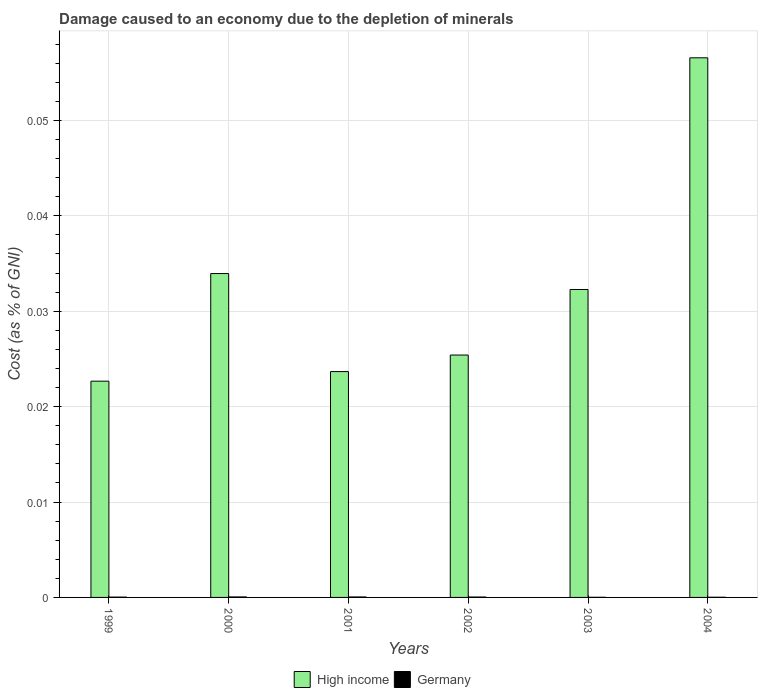How many different coloured bars are there?
Provide a succinct answer. 2. How many groups of bars are there?
Give a very brief answer. 6. How many bars are there on the 3rd tick from the left?
Offer a terse response. 2. In how many cases, is the number of bars for a given year not equal to the number of legend labels?
Your response must be concise. 0. What is the cost of damage caused due to the depletion of minerals in Germany in 1999?
Provide a short and direct response. 3.42242531159718e-5. Across all years, what is the maximum cost of damage caused due to the depletion of minerals in Germany?
Offer a very short reply. 5.218573212703661e-5. Across all years, what is the minimum cost of damage caused due to the depletion of minerals in High income?
Provide a short and direct response. 0.02. In which year was the cost of damage caused due to the depletion of minerals in Germany maximum?
Offer a terse response. 2000. What is the total cost of damage caused due to the depletion of minerals in Germany in the graph?
Your answer should be compact. 0. What is the difference between the cost of damage caused due to the depletion of minerals in Germany in 2000 and that in 2002?
Provide a short and direct response. 1.077346914888501e-5. What is the difference between the cost of damage caused due to the depletion of minerals in Germany in 2000 and the cost of damage caused due to the depletion of minerals in High income in 2002?
Offer a very short reply. -0.03. What is the average cost of damage caused due to the depletion of minerals in Germany per year?
Keep it short and to the point. 3.511987474264864e-5. In the year 2003, what is the difference between the cost of damage caused due to the depletion of minerals in High income and cost of damage caused due to the depletion of minerals in Germany?
Ensure brevity in your answer.  0.03. In how many years, is the cost of damage caused due to the depletion of minerals in Germany greater than 0.02 %?
Offer a terse response. 0. What is the ratio of the cost of damage caused due to the depletion of minerals in High income in 2000 to that in 2003?
Your answer should be compact. 1.05. Is the cost of damage caused due to the depletion of minerals in Germany in 2000 less than that in 2004?
Offer a very short reply. No. What is the difference between the highest and the second highest cost of damage caused due to the depletion of minerals in High income?
Offer a very short reply. 0.02. What is the difference between the highest and the lowest cost of damage caused due to the depletion of minerals in High income?
Provide a short and direct response. 0.03. What does the 2nd bar from the right in 2001 represents?
Provide a succinct answer. High income. How many bars are there?
Give a very brief answer. 12. How many years are there in the graph?
Your answer should be very brief. 6. What is the difference between two consecutive major ticks on the Y-axis?
Your answer should be very brief. 0.01. Does the graph contain any zero values?
Your answer should be compact. No. Where does the legend appear in the graph?
Your response must be concise. Bottom center. How are the legend labels stacked?
Provide a succinct answer. Horizontal. What is the title of the graph?
Keep it short and to the point. Damage caused to an economy due to the depletion of minerals. Does "Canada" appear as one of the legend labels in the graph?
Your answer should be very brief. No. What is the label or title of the Y-axis?
Offer a very short reply. Cost (as % of GNI). What is the Cost (as % of GNI) in High income in 1999?
Make the answer very short. 0.02. What is the Cost (as % of GNI) in Germany in 1999?
Keep it short and to the point. 3.42242531159718e-5. What is the Cost (as % of GNI) of High income in 2000?
Ensure brevity in your answer.  0.03. What is the Cost (as % of GNI) of Germany in 2000?
Make the answer very short. 5.218573212703661e-5. What is the Cost (as % of GNI) in High income in 2001?
Give a very brief answer. 0.02. What is the Cost (as % of GNI) in Germany in 2001?
Offer a very short reply. 4.8714493152778e-5. What is the Cost (as % of GNI) of High income in 2002?
Your response must be concise. 0.03. What is the Cost (as % of GNI) in Germany in 2002?
Your response must be concise. 4.14122629781516e-5. What is the Cost (as % of GNI) of High income in 2003?
Provide a succinct answer. 0.03. What is the Cost (as % of GNI) in Germany in 2003?
Ensure brevity in your answer.  1.49081092757522e-5. What is the Cost (as % of GNI) of High income in 2004?
Your response must be concise. 0.06. What is the Cost (as % of GNI) in Germany in 2004?
Ensure brevity in your answer.  1.927439780620161e-5. Across all years, what is the maximum Cost (as % of GNI) in High income?
Make the answer very short. 0.06. Across all years, what is the maximum Cost (as % of GNI) in Germany?
Offer a very short reply. 5.218573212703661e-5. Across all years, what is the minimum Cost (as % of GNI) in High income?
Your answer should be very brief. 0.02. Across all years, what is the minimum Cost (as % of GNI) of Germany?
Keep it short and to the point. 1.49081092757522e-5. What is the total Cost (as % of GNI) in High income in the graph?
Give a very brief answer. 0.19. What is the difference between the Cost (as % of GNI) in High income in 1999 and that in 2000?
Keep it short and to the point. -0.01. What is the difference between the Cost (as % of GNI) of High income in 1999 and that in 2001?
Your answer should be very brief. -0. What is the difference between the Cost (as % of GNI) in High income in 1999 and that in 2002?
Your answer should be very brief. -0. What is the difference between the Cost (as % of GNI) of Germany in 1999 and that in 2002?
Make the answer very short. -0. What is the difference between the Cost (as % of GNI) of High income in 1999 and that in 2003?
Offer a very short reply. -0.01. What is the difference between the Cost (as % of GNI) in High income in 1999 and that in 2004?
Offer a terse response. -0.03. What is the difference between the Cost (as % of GNI) in High income in 2000 and that in 2001?
Provide a short and direct response. 0.01. What is the difference between the Cost (as % of GNI) in High income in 2000 and that in 2002?
Provide a short and direct response. 0.01. What is the difference between the Cost (as % of GNI) of Germany in 2000 and that in 2002?
Your response must be concise. 0. What is the difference between the Cost (as % of GNI) of High income in 2000 and that in 2003?
Your answer should be compact. 0. What is the difference between the Cost (as % of GNI) of Germany in 2000 and that in 2003?
Your answer should be compact. 0. What is the difference between the Cost (as % of GNI) of High income in 2000 and that in 2004?
Offer a very short reply. -0.02. What is the difference between the Cost (as % of GNI) in Germany in 2000 and that in 2004?
Keep it short and to the point. 0. What is the difference between the Cost (as % of GNI) of High income in 2001 and that in 2002?
Your response must be concise. -0. What is the difference between the Cost (as % of GNI) of Germany in 2001 and that in 2002?
Ensure brevity in your answer.  0. What is the difference between the Cost (as % of GNI) in High income in 2001 and that in 2003?
Your answer should be very brief. -0.01. What is the difference between the Cost (as % of GNI) in High income in 2001 and that in 2004?
Your response must be concise. -0.03. What is the difference between the Cost (as % of GNI) of High income in 2002 and that in 2003?
Give a very brief answer. -0.01. What is the difference between the Cost (as % of GNI) in Germany in 2002 and that in 2003?
Your answer should be compact. 0. What is the difference between the Cost (as % of GNI) of High income in 2002 and that in 2004?
Offer a very short reply. -0.03. What is the difference between the Cost (as % of GNI) of High income in 2003 and that in 2004?
Keep it short and to the point. -0.02. What is the difference between the Cost (as % of GNI) in Germany in 2003 and that in 2004?
Your answer should be very brief. -0. What is the difference between the Cost (as % of GNI) of High income in 1999 and the Cost (as % of GNI) of Germany in 2000?
Provide a succinct answer. 0.02. What is the difference between the Cost (as % of GNI) of High income in 1999 and the Cost (as % of GNI) of Germany in 2001?
Your answer should be compact. 0.02. What is the difference between the Cost (as % of GNI) of High income in 1999 and the Cost (as % of GNI) of Germany in 2002?
Your answer should be compact. 0.02. What is the difference between the Cost (as % of GNI) of High income in 1999 and the Cost (as % of GNI) of Germany in 2003?
Make the answer very short. 0.02. What is the difference between the Cost (as % of GNI) of High income in 1999 and the Cost (as % of GNI) of Germany in 2004?
Give a very brief answer. 0.02. What is the difference between the Cost (as % of GNI) of High income in 2000 and the Cost (as % of GNI) of Germany in 2001?
Your response must be concise. 0.03. What is the difference between the Cost (as % of GNI) in High income in 2000 and the Cost (as % of GNI) in Germany in 2002?
Give a very brief answer. 0.03. What is the difference between the Cost (as % of GNI) in High income in 2000 and the Cost (as % of GNI) in Germany in 2003?
Ensure brevity in your answer.  0.03. What is the difference between the Cost (as % of GNI) in High income in 2000 and the Cost (as % of GNI) in Germany in 2004?
Offer a very short reply. 0.03. What is the difference between the Cost (as % of GNI) of High income in 2001 and the Cost (as % of GNI) of Germany in 2002?
Ensure brevity in your answer.  0.02. What is the difference between the Cost (as % of GNI) of High income in 2001 and the Cost (as % of GNI) of Germany in 2003?
Your answer should be very brief. 0.02. What is the difference between the Cost (as % of GNI) in High income in 2001 and the Cost (as % of GNI) in Germany in 2004?
Give a very brief answer. 0.02. What is the difference between the Cost (as % of GNI) in High income in 2002 and the Cost (as % of GNI) in Germany in 2003?
Provide a succinct answer. 0.03. What is the difference between the Cost (as % of GNI) of High income in 2002 and the Cost (as % of GNI) of Germany in 2004?
Provide a succinct answer. 0.03. What is the difference between the Cost (as % of GNI) of High income in 2003 and the Cost (as % of GNI) of Germany in 2004?
Your response must be concise. 0.03. What is the average Cost (as % of GNI) of High income per year?
Offer a terse response. 0.03. In the year 1999, what is the difference between the Cost (as % of GNI) of High income and Cost (as % of GNI) of Germany?
Provide a short and direct response. 0.02. In the year 2000, what is the difference between the Cost (as % of GNI) in High income and Cost (as % of GNI) in Germany?
Provide a succinct answer. 0.03. In the year 2001, what is the difference between the Cost (as % of GNI) of High income and Cost (as % of GNI) of Germany?
Give a very brief answer. 0.02. In the year 2002, what is the difference between the Cost (as % of GNI) of High income and Cost (as % of GNI) of Germany?
Your response must be concise. 0.03. In the year 2003, what is the difference between the Cost (as % of GNI) in High income and Cost (as % of GNI) in Germany?
Your answer should be very brief. 0.03. In the year 2004, what is the difference between the Cost (as % of GNI) in High income and Cost (as % of GNI) in Germany?
Keep it short and to the point. 0.06. What is the ratio of the Cost (as % of GNI) of High income in 1999 to that in 2000?
Offer a very short reply. 0.67. What is the ratio of the Cost (as % of GNI) of Germany in 1999 to that in 2000?
Provide a succinct answer. 0.66. What is the ratio of the Cost (as % of GNI) of High income in 1999 to that in 2001?
Provide a short and direct response. 0.96. What is the ratio of the Cost (as % of GNI) in Germany in 1999 to that in 2001?
Offer a very short reply. 0.7. What is the ratio of the Cost (as % of GNI) in High income in 1999 to that in 2002?
Ensure brevity in your answer.  0.89. What is the ratio of the Cost (as % of GNI) of Germany in 1999 to that in 2002?
Your answer should be very brief. 0.83. What is the ratio of the Cost (as % of GNI) in High income in 1999 to that in 2003?
Ensure brevity in your answer.  0.7. What is the ratio of the Cost (as % of GNI) in Germany in 1999 to that in 2003?
Offer a terse response. 2.3. What is the ratio of the Cost (as % of GNI) of High income in 1999 to that in 2004?
Your response must be concise. 0.4. What is the ratio of the Cost (as % of GNI) in Germany in 1999 to that in 2004?
Your answer should be compact. 1.78. What is the ratio of the Cost (as % of GNI) in High income in 2000 to that in 2001?
Offer a terse response. 1.43. What is the ratio of the Cost (as % of GNI) in Germany in 2000 to that in 2001?
Your response must be concise. 1.07. What is the ratio of the Cost (as % of GNI) of High income in 2000 to that in 2002?
Offer a very short reply. 1.34. What is the ratio of the Cost (as % of GNI) in Germany in 2000 to that in 2002?
Provide a succinct answer. 1.26. What is the ratio of the Cost (as % of GNI) in High income in 2000 to that in 2003?
Your answer should be compact. 1.05. What is the ratio of the Cost (as % of GNI) of Germany in 2000 to that in 2003?
Provide a succinct answer. 3.5. What is the ratio of the Cost (as % of GNI) of High income in 2000 to that in 2004?
Provide a short and direct response. 0.6. What is the ratio of the Cost (as % of GNI) in Germany in 2000 to that in 2004?
Offer a terse response. 2.71. What is the ratio of the Cost (as % of GNI) of High income in 2001 to that in 2002?
Offer a terse response. 0.93. What is the ratio of the Cost (as % of GNI) in Germany in 2001 to that in 2002?
Keep it short and to the point. 1.18. What is the ratio of the Cost (as % of GNI) in High income in 2001 to that in 2003?
Your response must be concise. 0.73. What is the ratio of the Cost (as % of GNI) in Germany in 2001 to that in 2003?
Your answer should be very brief. 3.27. What is the ratio of the Cost (as % of GNI) of High income in 2001 to that in 2004?
Keep it short and to the point. 0.42. What is the ratio of the Cost (as % of GNI) of Germany in 2001 to that in 2004?
Offer a terse response. 2.53. What is the ratio of the Cost (as % of GNI) in High income in 2002 to that in 2003?
Make the answer very short. 0.79. What is the ratio of the Cost (as % of GNI) in Germany in 2002 to that in 2003?
Offer a very short reply. 2.78. What is the ratio of the Cost (as % of GNI) of High income in 2002 to that in 2004?
Your answer should be very brief. 0.45. What is the ratio of the Cost (as % of GNI) of Germany in 2002 to that in 2004?
Make the answer very short. 2.15. What is the ratio of the Cost (as % of GNI) of High income in 2003 to that in 2004?
Your answer should be compact. 0.57. What is the ratio of the Cost (as % of GNI) of Germany in 2003 to that in 2004?
Make the answer very short. 0.77. What is the difference between the highest and the second highest Cost (as % of GNI) of High income?
Offer a very short reply. 0.02. What is the difference between the highest and the lowest Cost (as % of GNI) of High income?
Your answer should be compact. 0.03. What is the difference between the highest and the lowest Cost (as % of GNI) in Germany?
Ensure brevity in your answer.  0. 